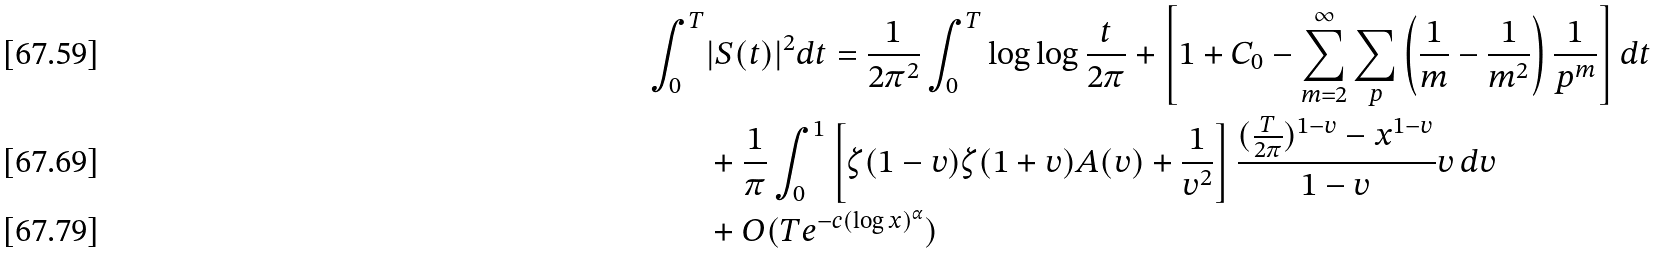<formula> <loc_0><loc_0><loc_500><loc_500>\int _ { 0 } ^ { T } & | S ( t ) | ^ { 2 } d t = \frac { 1 } { 2 \pi ^ { 2 } } \int _ { 0 } ^ { T } \log { \log { \frac { t } { 2 \pi } } } + \left [ 1 + C _ { 0 } - \sum _ { m = 2 } ^ { \infty } \sum _ { p } \left ( \frac { 1 } { m } - \frac { 1 } { m ^ { 2 } } \right ) \frac { 1 } { p ^ { m } } \right ] d t \\ & + \frac { 1 } { \pi } \int _ { 0 } ^ { 1 } \left [ \zeta ( 1 - v ) \zeta ( 1 + v ) A ( v ) + \frac { 1 } { v ^ { 2 } } \right ] \frac { ( \frac { T } { 2 \pi } ) ^ { 1 - v } - x ^ { 1 - v } } { 1 - v } v \, d v \\ & + O ( T e ^ { - c ( \log x ) ^ { \alpha } } )</formula> 